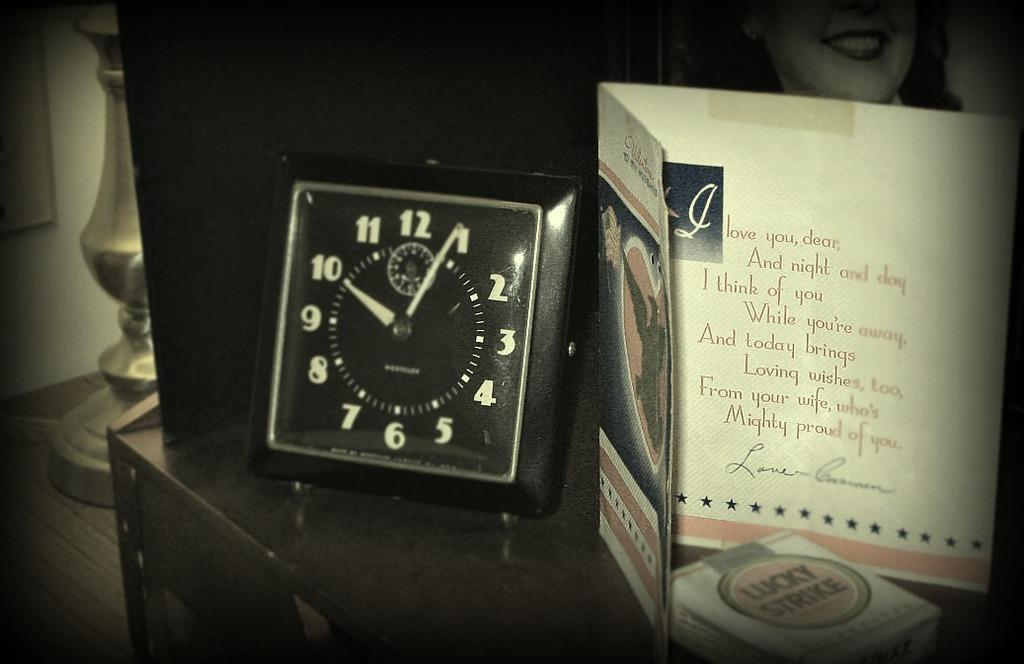Provide a one-sentence caption for the provided image. The card next to the clock starts of with, "I love you, dear.". 